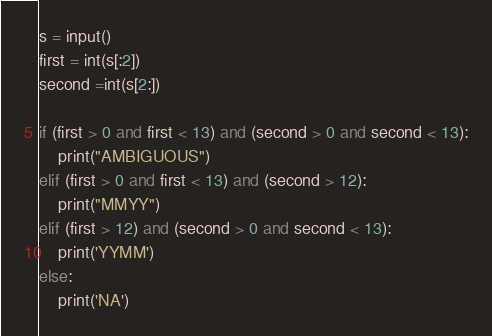Convert code to text. <code><loc_0><loc_0><loc_500><loc_500><_Python_>s = input()
first = int(s[:2])
second =int(s[2:])

if (first > 0 and first < 13) and (second > 0 and second < 13):
    print("AMBIGUOUS")
elif (first > 0 and first < 13) and (second > 12):
    print("MMYY")
elif (first > 12) and (second > 0 and second < 13):
    print('YYMM')
else:
    print('NA')

</code> 